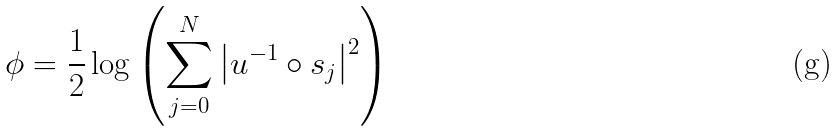<formula> <loc_0><loc_0><loc_500><loc_500>\phi = \frac { 1 } { 2 } \log \left ( \overset { N } { \underset { j = 0 } { \sum } } \left | u ^ { - 1 } \circ s _ { j } \right | ^ { 2 } \right )</formula> 